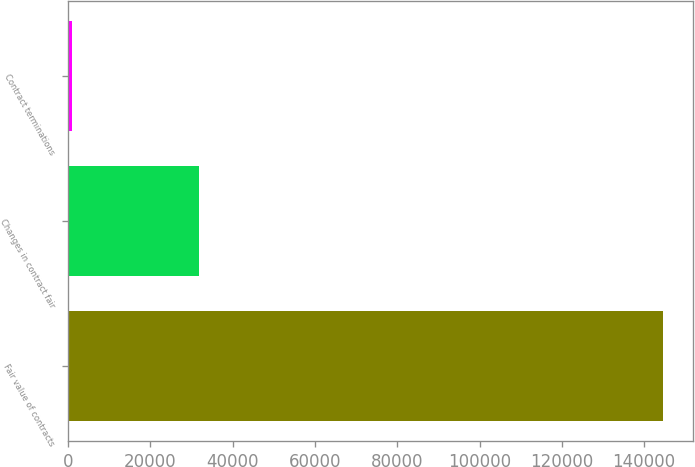Convert chart to OTSL. <chart><loc_0><loc_0><loc_500><loc_500><bar_chart><fcel>Fair value of contracts<fcel>Changes in contract fair<fcel>Contract terminations<nl><fcel>144532<fcel>31735.6<fcel>967<nl></chart> 